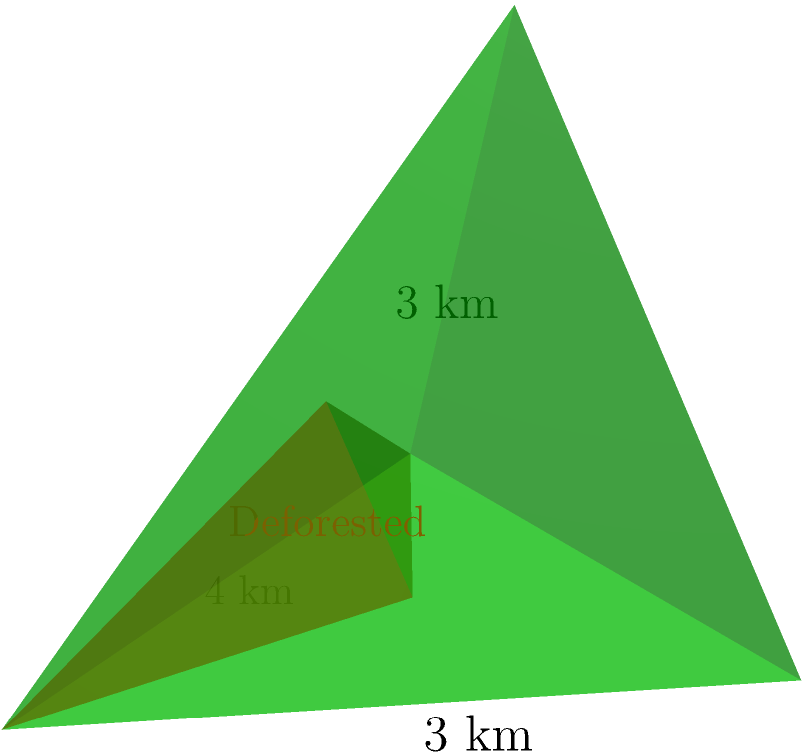A pyramid-shaped mountain has a square base with sides of 4 km and a height of 3 km. If deforestation has affected the lower third of the mountain's height, what percentage of the mountain's surface area (excluding the base) has been impacted? Let's approach this step-by-step:

1) First, we need to calculate the total surface area of the pyramid (excluding the base).

2) The pyramid has 4 triangular faces. We need to find the area of one face and multiply by 4.

3) To find the area of one face, we need its height. We can use the Pythagorean theorem:
   $$h^2 = 3^2 + 2^2 = 13$$
   $$h = \sqrt{13} \approx 3.61 \text{ km}$$

4) Area of one face: 
   $$A = \frac{1}{2} * 4 * 3.61 = 7.22 \text{ km}^2$$

5) Total surface area:
   $$SA_{total} = 4 * 7.22 = 28.88 \text{ km}^2$$

6) Now, we need to find the surface area of the deforested part. The deforested part is also a pyramid, with 1/3 the height of the original.

7) Height of the small pyramid: 3 km / 3 = 1 km

8) Using similar triangles, we can find that the base of the small pyramid is 4/3 km on each side.

9) Height of the face of the small pyramid:
   $$h_s^2 = 1^2 + (\frac{2}{3})^2 = \frac{13}{9}$$
   $$h_s = \sqrt{\frac{13}{9}} \approx 1.20 \text{ km}$$

10) Area of one face of the small pyramid:
    $$A_s = \frac{1}{2} * \frac{4}{3} * 1.20 = 0.80 \text{ km}^2$$

11) Total surface area of the small pyramid:
    $$SA_{deforested} = 4 * 0.80 = 3.20 \text{ km}^2$$

12) Percentage of surface area deforested:
    $$\frac{3.20}{28.88} * 100\% \approx 11.08\%$$
Answer: 11.08% 